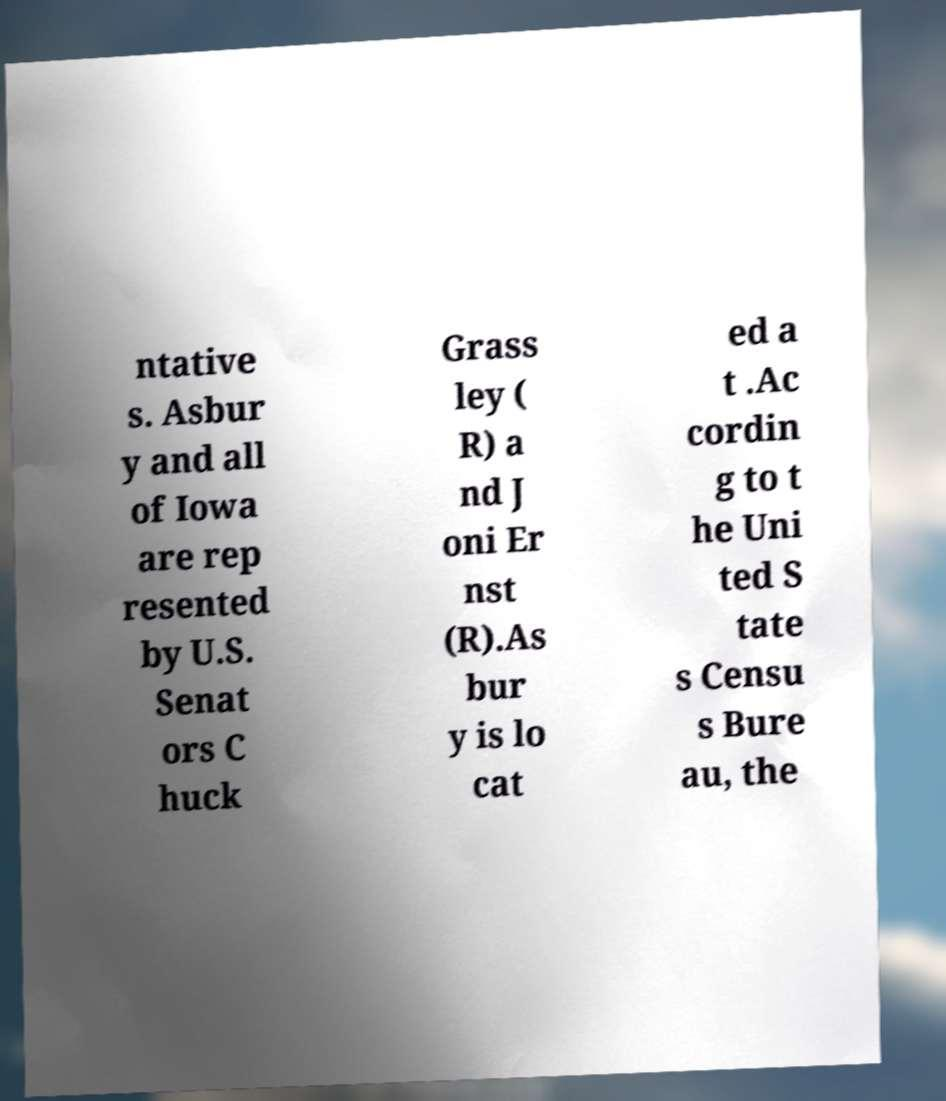For documentation purposes, I need the text within this image transcribed. Could you provide that? ntative s. Asbur y and all of Iowa are rep resented by U.S. Senat ors C huck Grass ley ( R) a nd J oni Er nst (R).As bur y is lo cat ed a t .Ac cordin g to t he Uni ted S tate s Censu s Bure au, the 